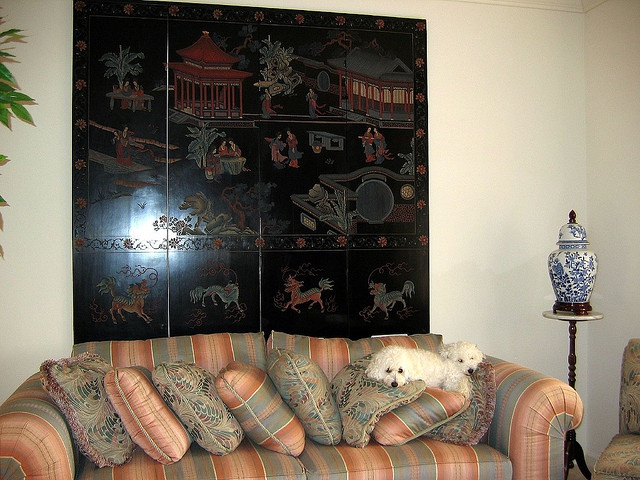Describe the objects in this image and their specific colors. I can see couch in gray and tan tones, vase in gray, darkgray, black, and lightgray tones, chair in gray and black tones, potted plant in gray, darkgray, darkgreen, and lightgray tones, and dog in gray, beige, and tan tones in this image. 